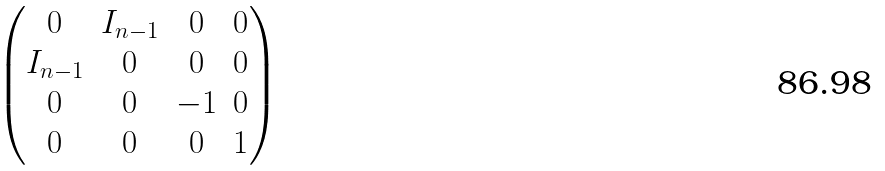Convert formula to latex. <formula><loc_0><loc_0><loc_500><loc_500>\begin{pmatrix} 0 & I _ { n - 1 } & 0 & 0 \\ I _ { n - 1 } & 0 & 0 & 0 \\ 0 & 0 & - 1 & 0 \\ 0 & 0 & 0 & 1 \\ \end{pmatrix}</formula> 